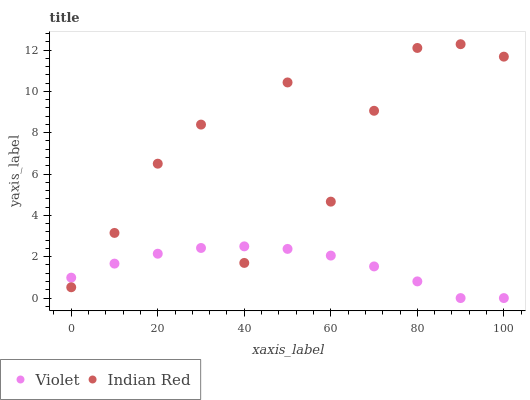Does Violet have the minimum area under the curve?
Answer yes or no. Yes. Does Indian Red have the maximum area under the curve?
Answer yes or no. Yes. Does Violet have the maximum area under the curve?
Answer yes or no. No. Is Violet the smoothest?
Answer yes or no. Yes. Is Indian Red the roughest?
Answer yes or no. Yes. Is Violet the roughest?
Answer yes or no. No. Does Violet have the lowest value?
Answer yes or no. Yes. Does Indian Red have the highest value?
Answer yes or no. Yes. Does Violet have the highest value?
Answer yes or no. No. Does Indian Red intersect Violet?
Answer yes or no. Yes. Is Indian Red less than Violet?
Answer yes or no. No. Is Indian Red greater than Violet?
Answer yes or no. No. 